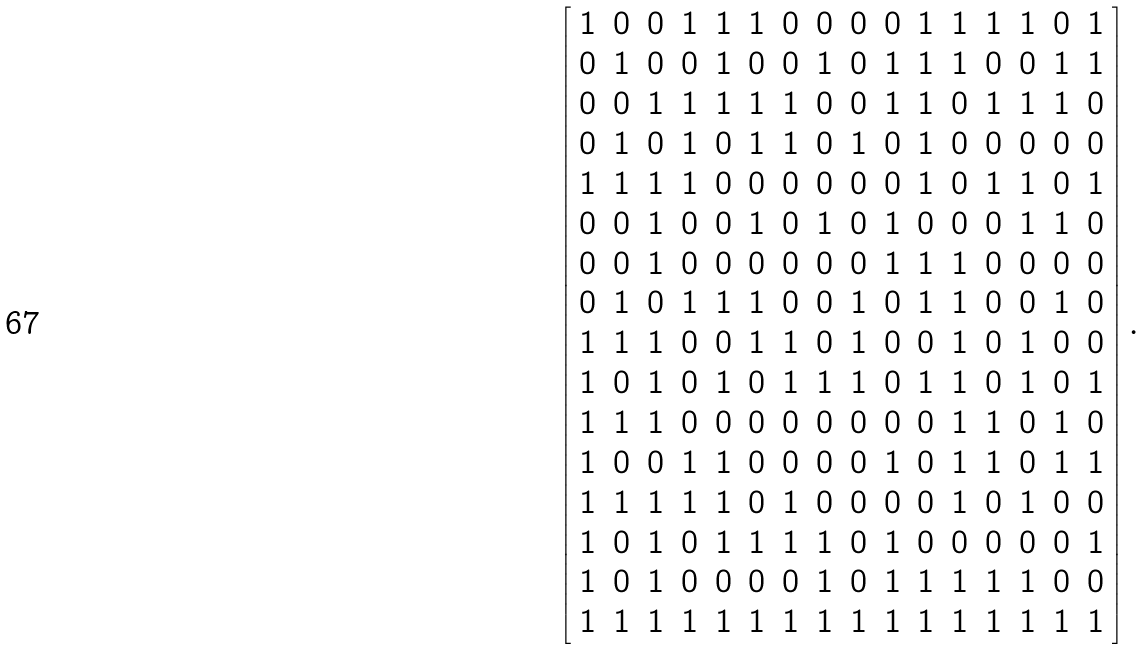<formula> <loc_0><loc_0><loc_500><loc_500>\left [ \begin{array} { c c c c c c c c c c c c c c c c } 1 & 0 & 0 & 1 & 1 & 1 & 0 & 0 & 0 & 0 & 1 & 1 & 1 & 1 & 0 & 1 \\ 0 & 1 & 0 & 0 & 1 & 0 & 0 & 1 & 0 & 1 & 1 & 1 & 0 & 0 & 1 & 1 \\ 0 & 0 & 1 & 1 & 1 & 1 & 1 & 0 & 0 & 1 & 1 & 0 & 1 & 1 & 1 & 0 \\ 0 & 1 & 0 & 1 & 0 & 1 & 1 & 0 & 1 & 0 & 1 & 0 & 0 & 0 & 0 & 0 \\ 1 & 1 & 1 & 1 & 0 & 0 & 0 & 0 & 0 & 0 & 1 & 0 & 1 & 1 & 0 & 1 \\ 0 & 0 & 1 & 0 & 0 & 1 & 0 & 1 & 0 & 1 & 0 & 0 & 0 & 1 & 1 & 0 \\ 0 & 0 & 1 & 0 & 0 & 0 & 0 & 0 & 0 & 1 & 1 & 1 & 0 & 0 & 0 & 0 \\ 0 & 1 & 0 & 1 & 1 & 1 & 0 & 0 & 1 & 0 & 1 & 1 & 0 & 0 & 1 & 0 \\ 1 & 1 & 1 & 0 & 0 & 1 & 1 & 0 & 1 & 0 & 0 & 1 & 0 & 1 & 0 & 0 \\ 1 & 0 & 1 & 0 & 1 & 0 & 1 & 1 & 1 & 0 & 1 & 1 & 0 & 1 & 0 & 1 \\ 1 & 1 & 1 & 0 & 0 & 0 & 0 & 0 & 0 & 0 & 0 & 1 & 1 & 0 & 1 & 0 \\ 1 & 0 & 0 & 1 & 1 & 0 & 0 & 0 & 0 & 1 & 0 & 1 & 1 & 0 & 1 & 1 \\ 1 & 1 & 1 & 1 & 1 & 0 & 1 & 0 & 0 & 0 & 0 & 1 & 0 & 1 & 0 & 0 \\ 1 & 0 & 1 & 0 & 1 & 1 & 1 & 1 & 0 & 1 & 0 & 0 & 0 & 0 & 0 & 1 \\ 1 & 0 & 1 & 0 & 0 & 0 & 0 & 1 & 0 & 1 & 1 & 1 & 1 & 1 & 0 & 0 \\ 1 & 1 & 1 & 1 & 1 & 1 & 1 & 1 & 1 & 1 & 1 & 1 & 1 & 1 & 1 & 1 \\ \end{array} \right ] .</formula> 